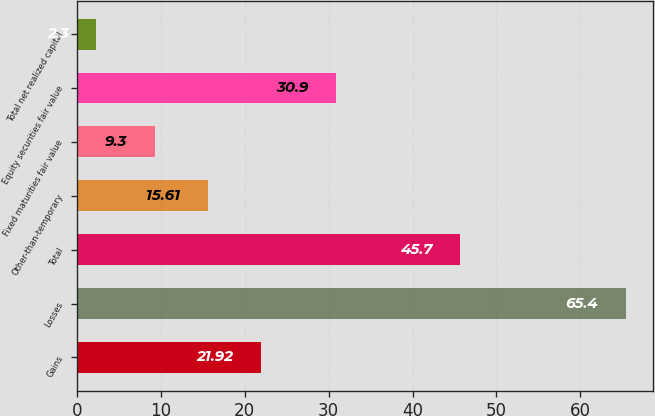Convert chart to OTSL. <chart><loc_0><loc_0><loc_500><loc_500><bar_chart><fcel>Gains<fcel>Losses<fcel>Total<fcel>Other-than-temporary<fcel>Fixed maturities fair value<fcel>Equity securities fair value<fcel>Total net realized capital<nl><fcel>21.92<fcel>65.4<fcel>45.7<fcel>15.61<fcel>9.3<fcel>30.9<fcel>2.3<nl></chart> 